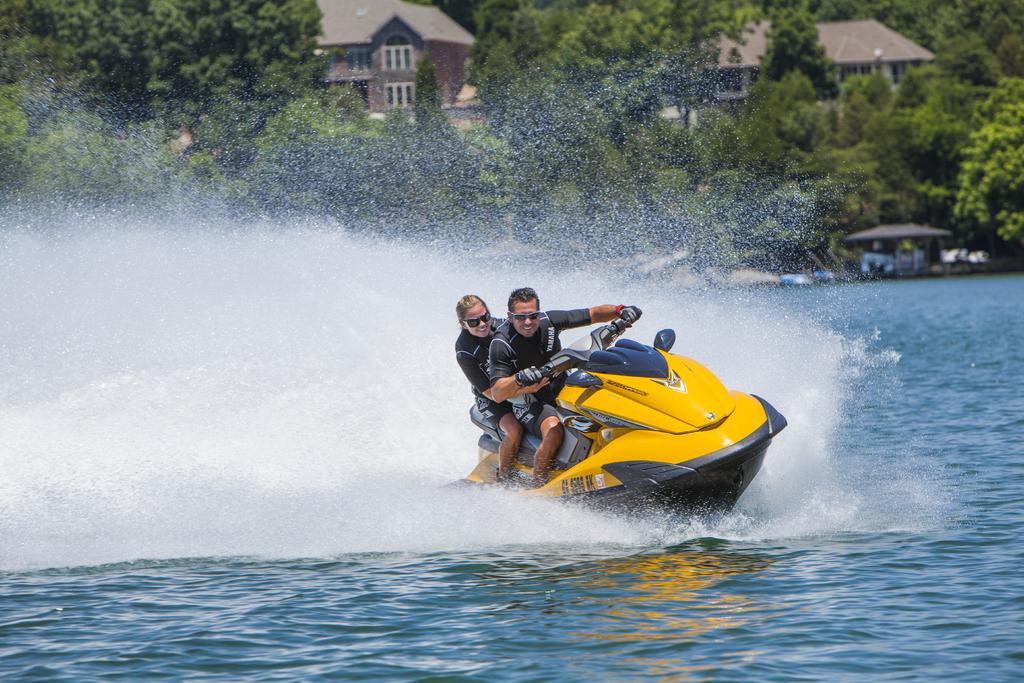What type of natural elements can be seen in the image? There are trees in the image. What type of structures are visible in the image? There are roof houses in the image. How many people are present in the image? There are two persons in the image. What are the two persons doing in the image? The two persons are sitting on a speed boat. What is the speed boat doing in the image? The speed boat is floating on the water. What is the name of the person sitting on the cushion in the image? There is no cushion present in the image, and no names are mentioned or visible. 